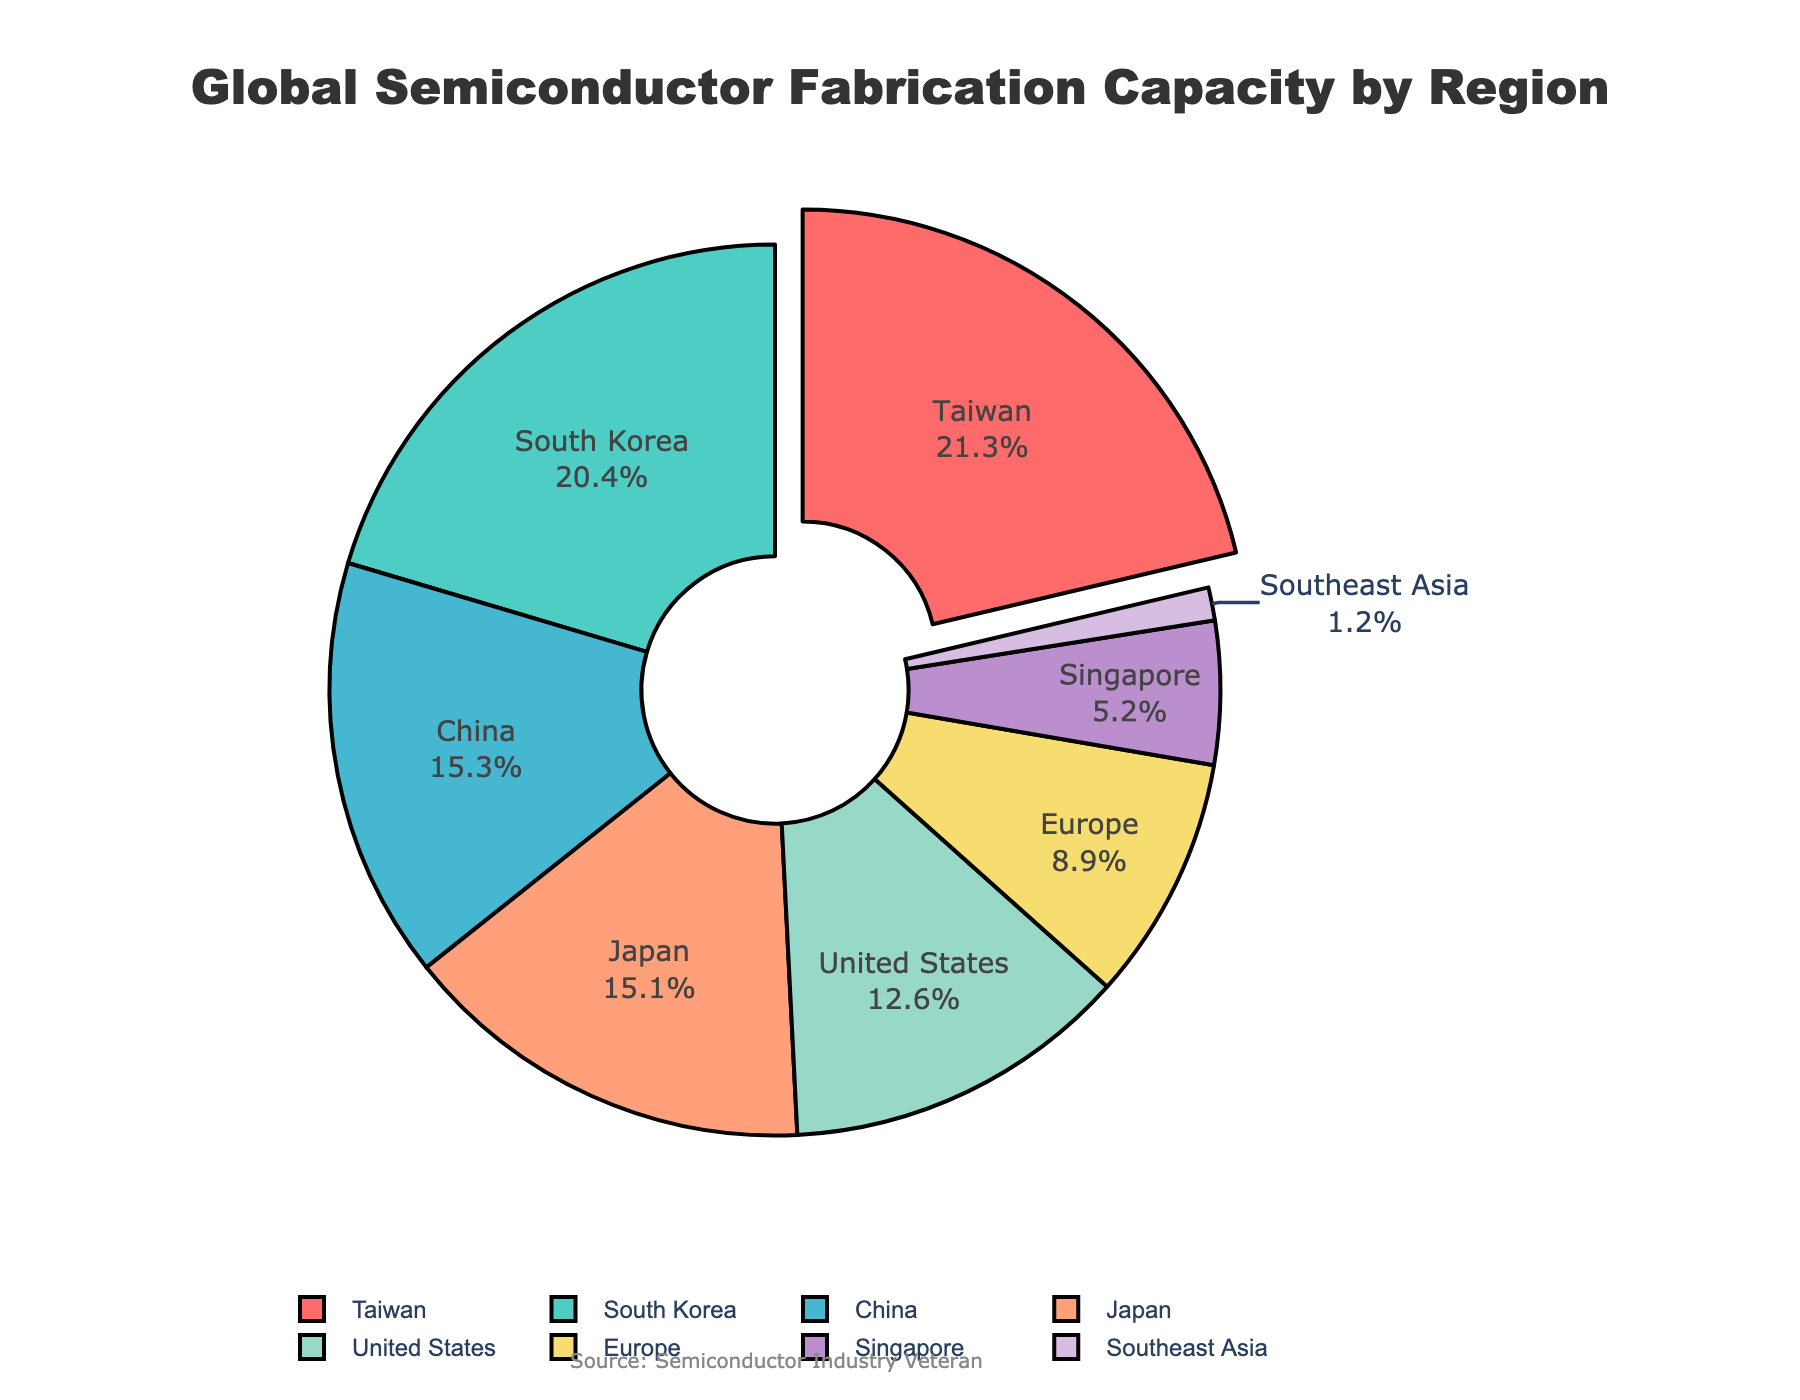Which region has the largest share of global semiconductor fabrication capacity? The region with the largest share is marked by a segment pulled out from the pie chart, which is Taiwan with 21.3%.
Answer: Taiwan Which two regions together account for the largest portion of global semiconductor fabrication capacity? By summing the percentages of the two largest regions, Taiwan (21.3%) and South Korea (20.4%), we get 21.3% + 20.4% = 41.7%.
Answer: Taiwan and South Korea How much more percentage does Taiwan have over the United States? Subtract the percentage of the United States (12.6%) from Taiwan's percentage (21.3%), resulting in 21.3% - 12.6% = 8.7%.
Answer: 8.7% What is the combined capacity percentage of Europe, Singapore, and Southeast Asia? Adding the percentage of Europe (8.9%), Singapore (5.2%), and Southeast Asia (1.2%) gives 8.9% + 5.2% + 1.2% = 15.3%.
Answer: 15.3% Which region has the third largest capacity percentage? Starting from the largest to third largest, these regions are Taiwan (21.3%), South Korea (20.4%), and China (15.3%).
Answer: China Is Japan's semiconductor capacity greater than that of Europe and Singapore combined? Compare Japan's percentage (15.1%) with the sum of Europe (8.9%) and Singapore (5.2%), which is 8.9% + 5.2% = 14.1%. Since 15.1% > 14.1%, Japan's capacity is indeed greater.
Answer: Yes What regions have capacity percentages less than 10%? The regions with less than 10% include Europe (8.9%), Singapore (5.2%), and Southeast Asia (1.2%).
Answer: Europe, Singapore, Southeast Asia How many regions have a capacity percentage higher than 15%? From the chart, the regions with more than 15% are Taiwan (21.3%), South Korea (20.4%), and China (15.3%). Counting these gives a total of three regions.
Answer: Three regions Which region's data segment is displayed in green? The pie chart segment displaying the color green represents the South Korea region.
Answer: South Korea 